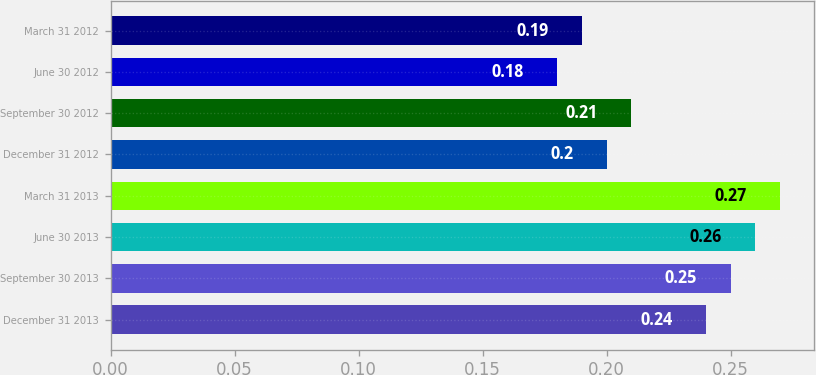Convert chart to OTSL. <chart><loc_0><loc_0><loc_500><loc_500><bar_chart><fcel>December 31 2013<fcel>September 30 2013<fcel>June 30 2013<fcel>March 31 2013<fcel>December 31 2012<fcel>September 30 2012<fcel>June 30 2012<fcel>March 31 2012<nl><fcel>0.24<fcel>0.25<fcel>0.26<fcel>0.27<fcel>0.2<fcel>0.21<fcel>0.18<fcel>0.19<nl></chart> 